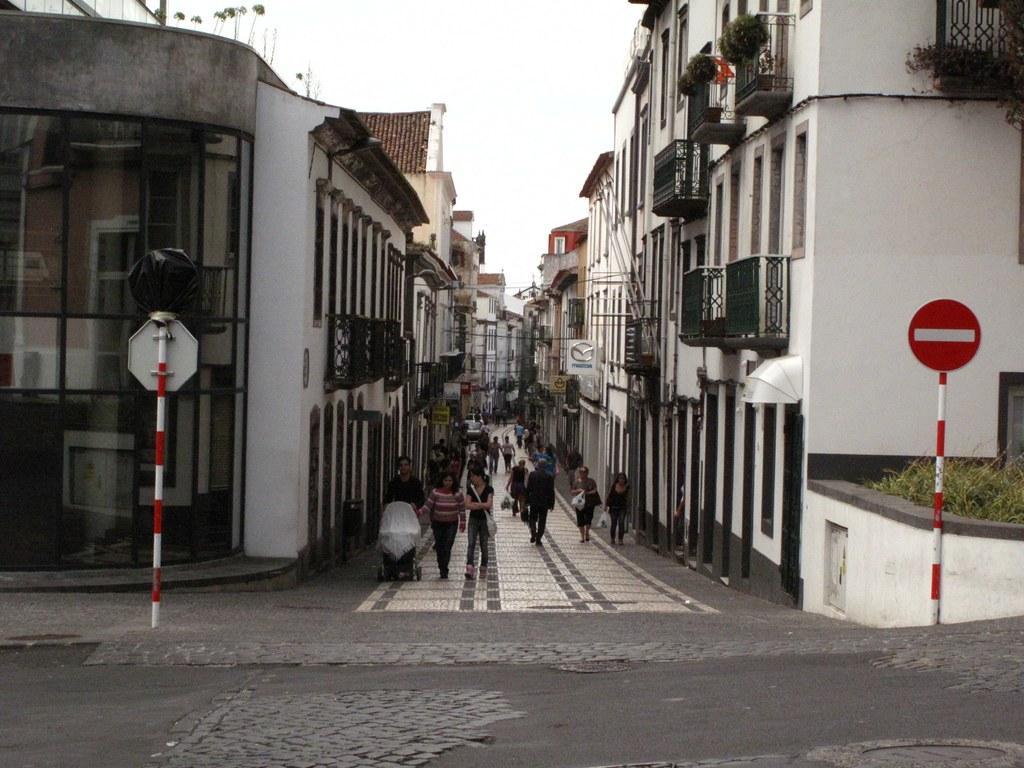Can you describe this image briefly? In this image I can see the road, the street and few persons standing on the street. I can see few buildings on both sides of the street, two poles and few sign boards attached to the poles. I can see few plants. In the background I can see the sky. 